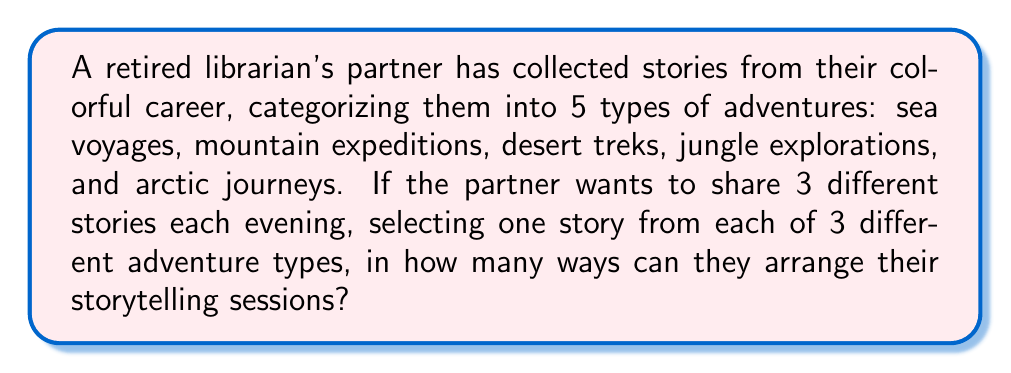Teach me how to tackle this problem. Let's approach this step-by-step:

1) First, we need to choose which 3 adventure types out of the 5 will be used for the evening's stories. This is a combination problem, represented as $\binom{5}{3}$.

   $$\binom{5}{3} = \frac{5!}{3!(5-3)!} = \frac{5!}{3!2!} = 10$$

2) Now, for each of these 10 combinations of adventure types, we need to arrange them in order. This is a permutation of 3 items, which is simply 3!.

   $$3! = 3 \times 2 \times 1 = 6$$

3) So far, we have 10 ways to choose the adventure types, and 6 ways to arrange each choice. By the multiplication principle, this gives us $10 \times 6 = 60$ different arrangements of adventure types.

4) However, we're not done yet. For each adventure type, the partner needs to choose one story. We don't know how many stories are in each category, but we know there's at least one in each. So for each of our 60 arrangements, we need to make 3 more choices (one for each adventure type in the arrangement).

5) By the multiplication principle again, our final answer will be:

   $$60 \times x \times y \times z$$

   Where $x$, $y$, and $z$ represent the number of stories in each of the three chosen adventure types.

6) Without knowing the specific numbers of stories in each category, we can express our final answer as:

   $$60xyz$$

   Where $x$, $y$, and $z$ are positive integers representing the number of stories in each of the three chosen adventure types for a given arrangement.
Answer: $60xyz$, where $x$, $y$, $z$ are positive integers 